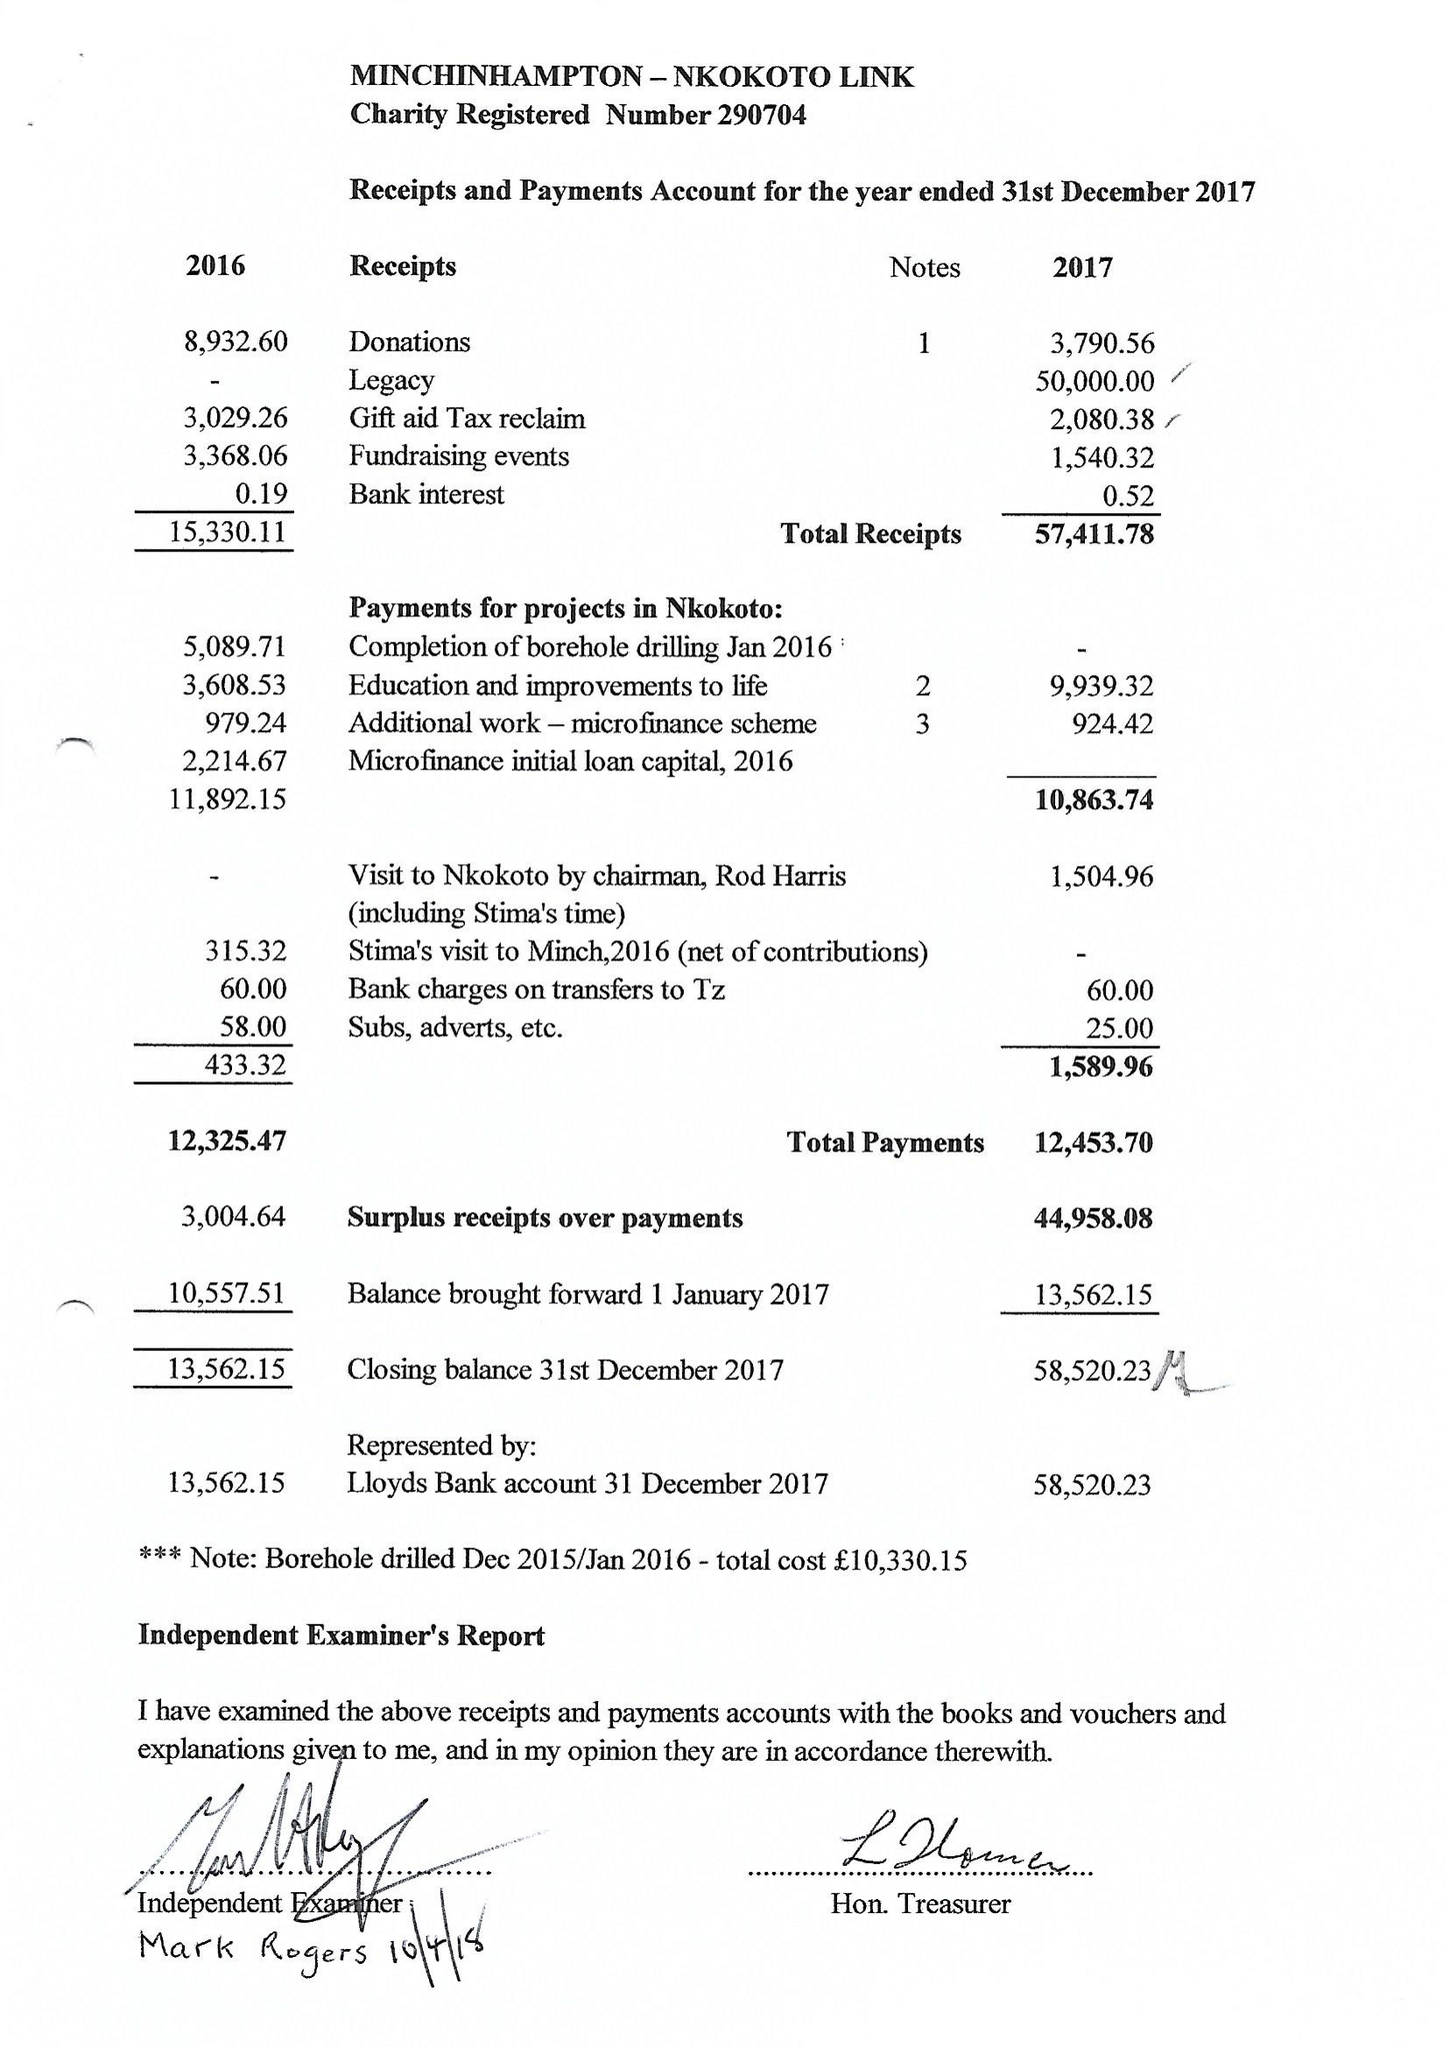What is the value for the spending_annually_in_british_pounds?
Answer the question using a single word or phrase. 12454.00 